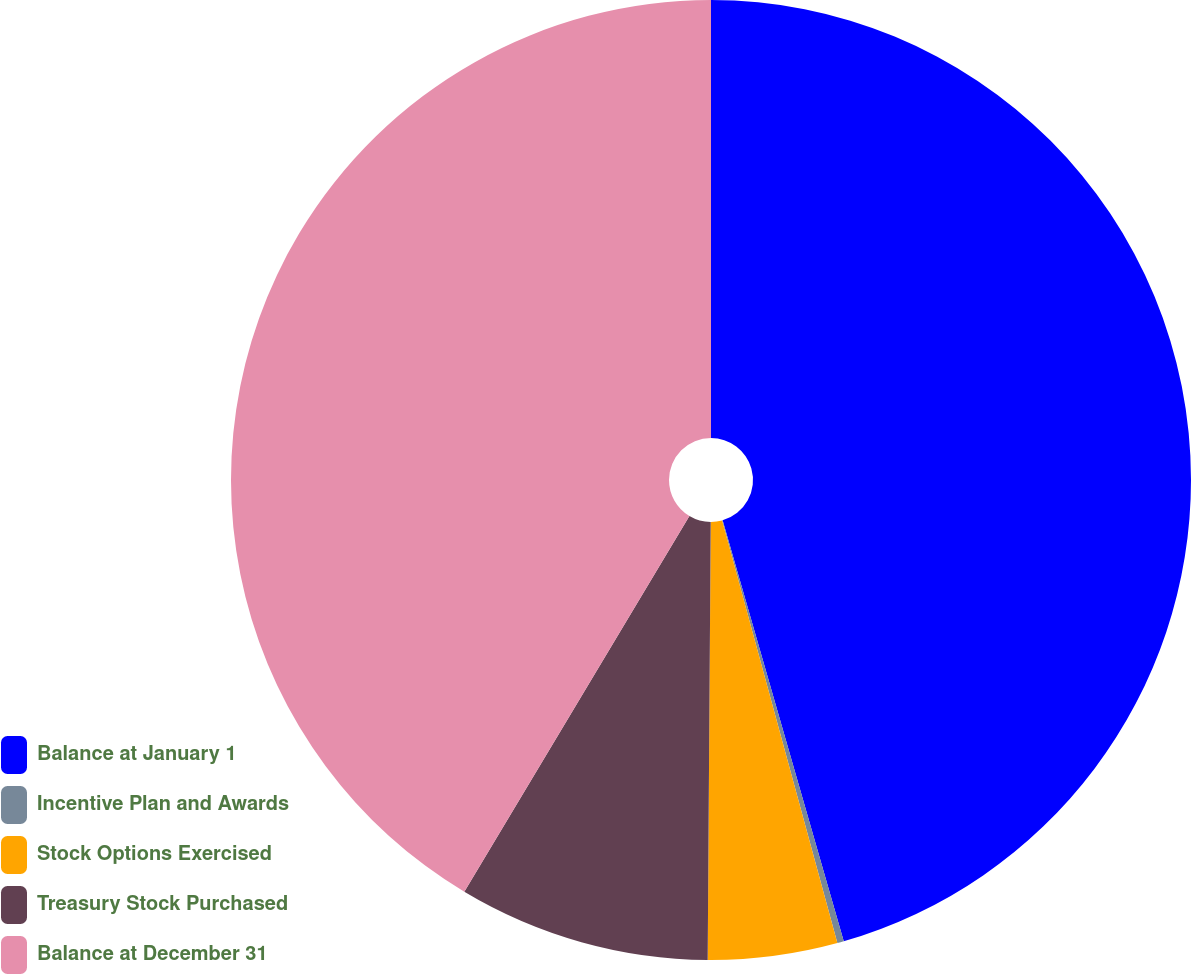Convert chart. <chart><loc_0><loc_0><loc_500><loc_500><pie_chart><fcel>Balance at January 1<fcel>Incentive Plan and Awards<fcel>Stock Options Exercised<fcel>Treasury Stock Purchased<fcel>Balance at December 31<nl><fcel>45.54%<fcel>0.22%<fcel>4.35%<fcel>8.48%<fcel>41.41%<nl></chart> 